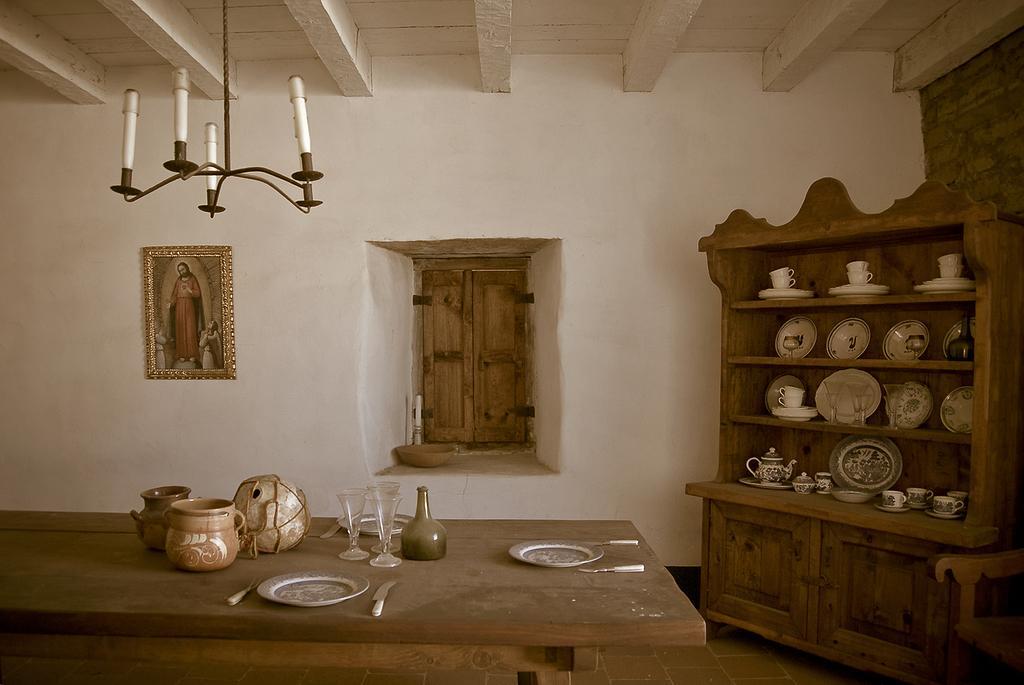Could you give a brief overview of what you see in this image? In this image we can see a table and plates and glasses and some objects on it, and here is the wall and photo frame on it, and at side her is the window, and at side here is the table and some objects on it, and at above her is the roof. 